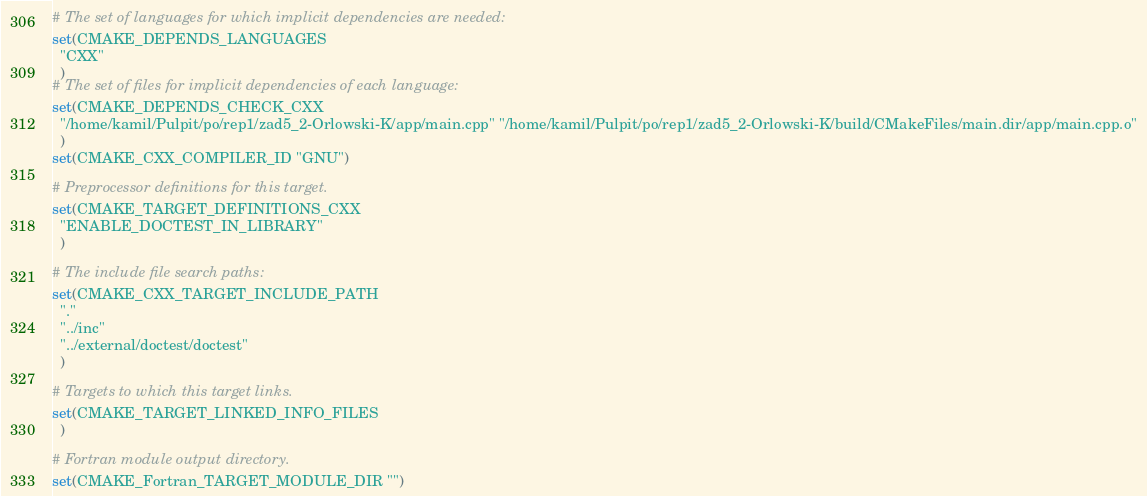<code> <loc_0><loc_0><loc_500><loc_500><_CMake_># The set of languages for which implicit dependencies are needed:
set(CMAKE_DEPENDS_LANGUAGES
  "CXX"
  )
# The set of files for implicit dependencies of each language:
set(CMAKE_DEPENDS_CHECK_CXX
  "/home/kamil/Pulpit/po/rep1/zad5_2-Orlowski-K/app/main.cpp" "/home/kamil/Pulpit/po/rep1/zad5_2-Orlowski-K/build/CMakeFiles/main.dir/app/main.cpp.o"
  )
set(CMAKE_CXX_COMPILER_ID "GNU")

# Preprocessor definitions for this target.
set(CMAKE_TARGET_DEFINITIONS_CXX
  "ENABLE_DOCTEST_IN_LIBRARY"
  )

# The include file search paths:
set(CMAKE_CXX_TARGET_INCLUDE_PATH
  "."
  "../inc"
  "../external/doctest/doctest"
  )

# Targets to which this target links.
set(CMAKE_TARGET_LINKED_INFO_FILES
  )

# Fortran module output directory.
set(CMAKE_Fortran_TARGET_MODULE_DIR "")
</code> 